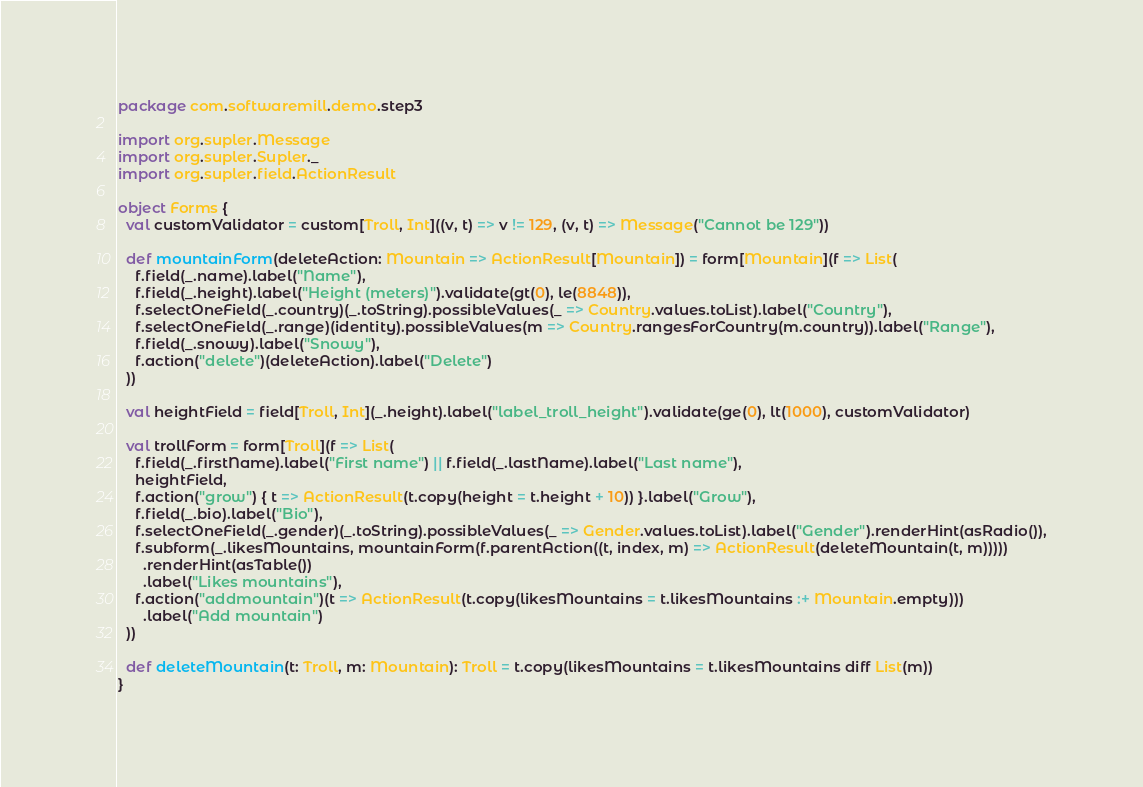Convert code to text. <code><loc_0><loc_0><loc_500><loc_500><_Scala_>package com.softwaremill.demo.step3

import org.supler.Message
import org.supler.Supler._
import org.supler.field.ActionResult

object Forms {
  val customValidator = custom[Troll, Int]((v, t) => v != 129, (v, t) => Message("Cannot be 129"))

  def mountainForm(deleteAction: Mountain => ActionResult[Mountain]) = form[Mountain](f => List(
    f.field(_.name).label("Name"),
    f.field(_.height).label("Height (meters)").validate(gt(0), le(8848)),
    f.selectOneField(_.country)(_.toString).possibleValues(_ => Country.values.toList).label("Country"),
    f.selectOneField(_.range)(identity).possibleValues(m => Country.rangesForCountry(m.country)).label("Range"),
    f.field(_.snowy).label("Snowy"),
    f.action("delete")(deleteAction).label("Delete")
  ))

  val heightField = field[Troll, Int](_.height).label("label_troll_height").validate(ge(0), lt(1000), customValidator)

  val trollForm = form[Troll](f => List(
    f.field(_.firstName).label("First name") || f.field(_.lastName).label("Last name"),
    heightField,
    f.action("grow") { t => ActionResult(t.copy(height = t.height + 10)) }.label("Grow"),
    f.field(_.bio).label("Bio"),
    f.selectOneField(_.gender)(_.toString).possibleValues(_ => Gender.values.toList).label("Gender").renderHint(asRadio()),
    f.subform(_.likesMountains, mountainForm(f.parentAction((t, index, m) => ActionResult(deleteMountain(t, m)))))
      .renderHint(asTable())
      .label("Likes mountains"),
    f.action("addmountain")(t => ActionResult(t.copy(likesMountains = t.likesMountains :+ Mountain.empty)))
      .label("Add mountain")
  ))

  def deleteMountain(t: Troll, m: Mountain): Troll = t.copy(likesMountains = t.likesMountains diff List(m))
}</code> 